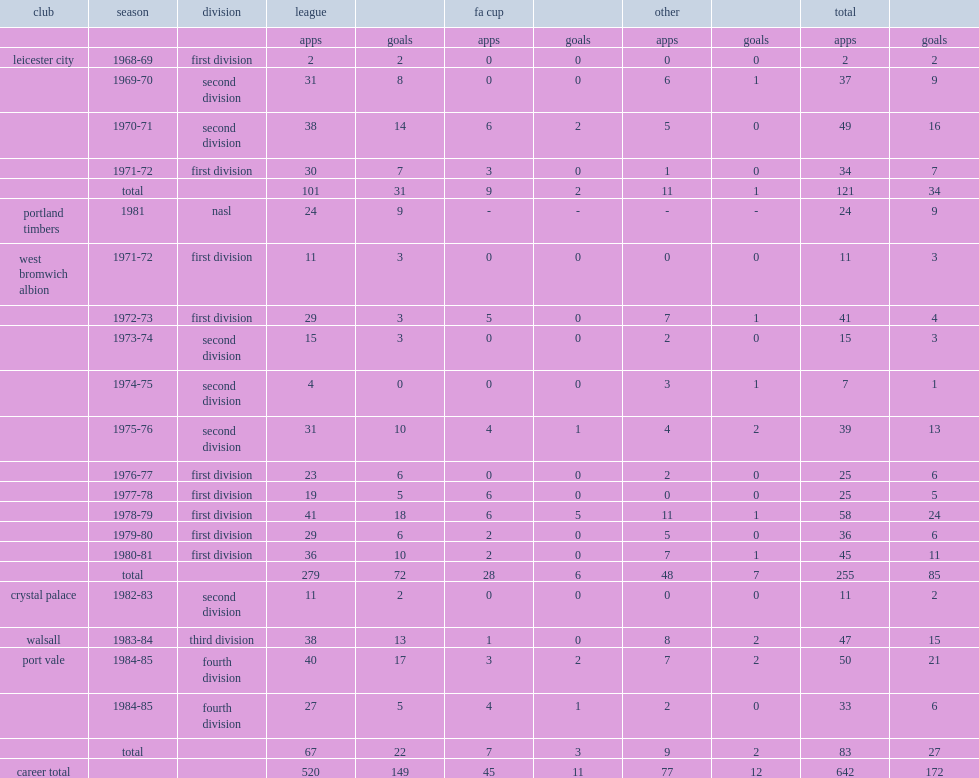How many league appearances did alistair brown make for the "baggies"? 279.0. 